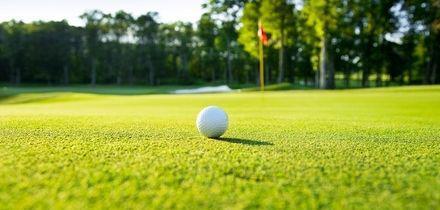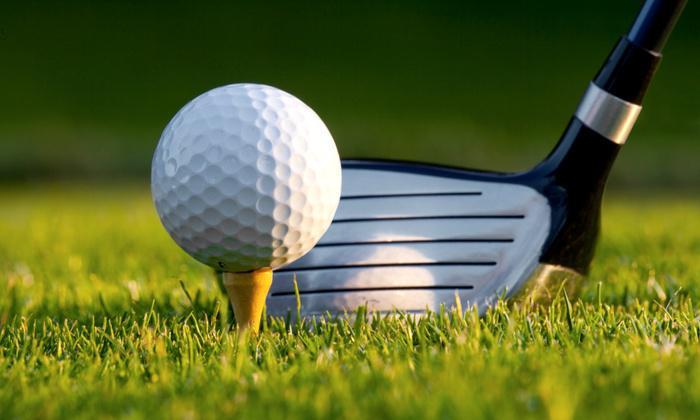The first image is the image on the left, the second image is the image on the right. Given the left and right images, does the statement "In the right image, a single golf ball on a tee and part of a golf club are visible" hold true? Answer yes or no. Yes. The first image is the image on the left, the second image is the image on the right. For the images displayed, is the sentence "a golf club is next to the ball" factually correct? Answer yes or no. Yes. 